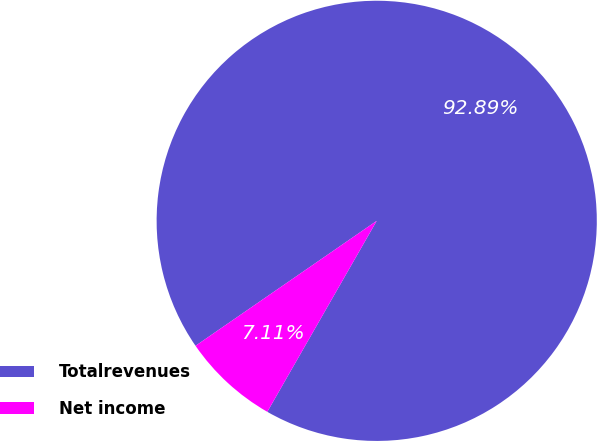<chart> <loc_0><loc_0><loc_500><loc_500><pie_chart><fcel>Totalrevenues<fcel>Net income<nl><fcel>92.89%<fcel>7.11%<nl></chart> 